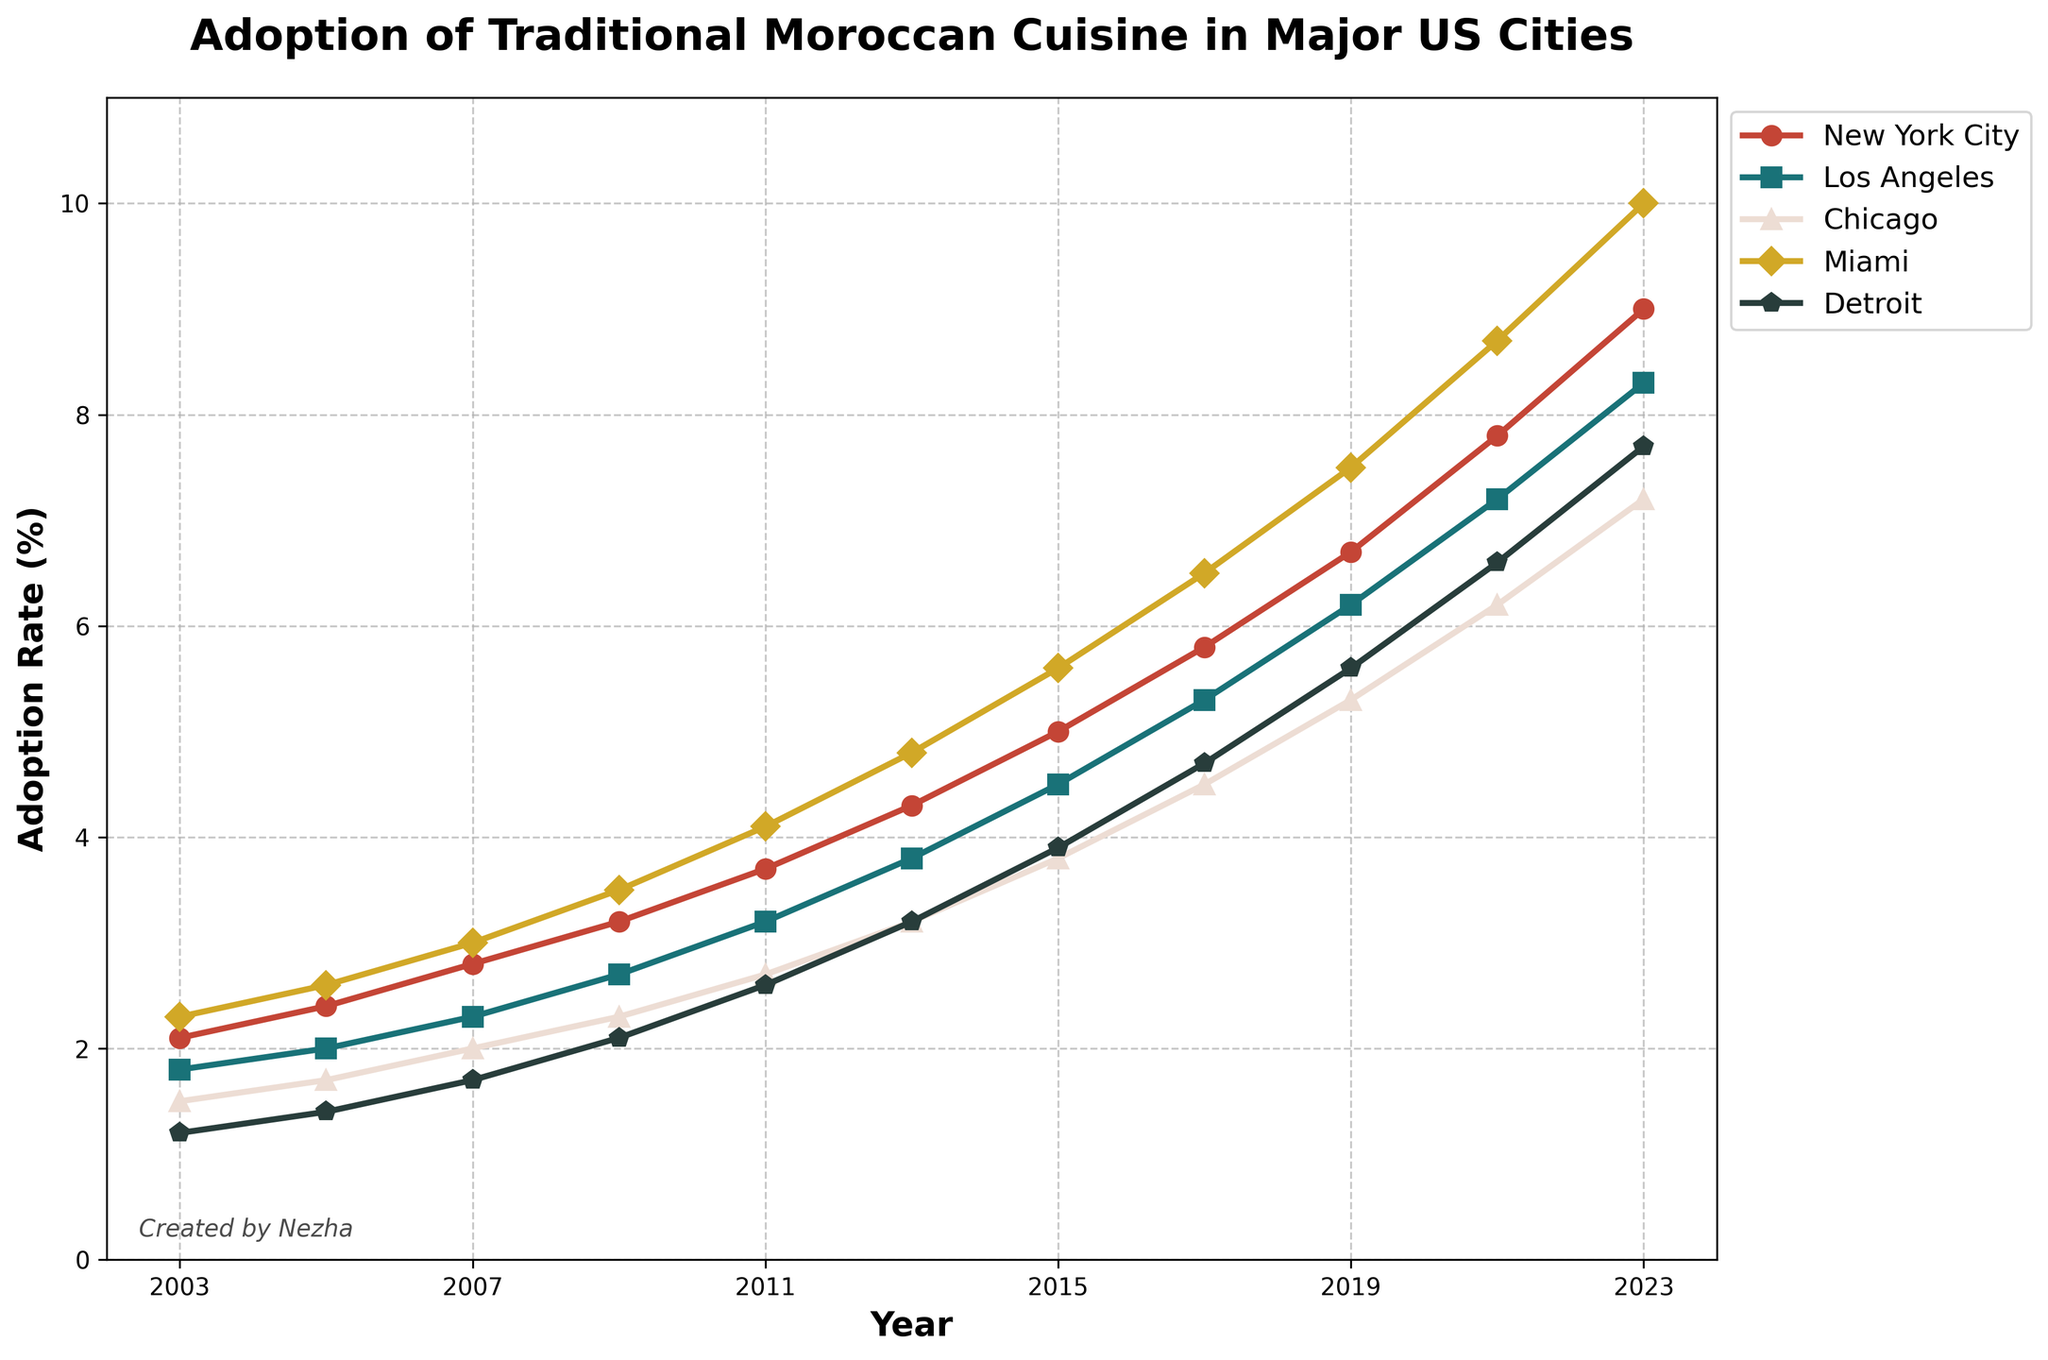Which city had the highest adoption rate of traditional Moroccan cuisine in 2023? To find the city with the highest adoption rate in 2023, we look at the data points for each city for the year 2023. Miami has the highest at 10.0%.
Answer: Miami How did the adoption rate in Detroit change from 2003 to 2023? First, identify the adoption rates in Detroit for 2003 and 2023. In 2003, it was 1.2%, and in 2023, it was 7.7%. The change is 7.7% - 1.2% = 6.5%.
Answer: Increased by 6.5% What is the average adoption rate of Moroccan cuisine in Chicago over the entire period? Sum the adoption rates in Chicago for each year and divide by the number of years: (1.5 + 1.7 + 2.0 + 2.3 + 2.7 + 3.2 + 3.8 + 4.5 + 5.3 + 6.2 + 7.2) / 11 = 3.73%.
Answer: 3.73% Which cities had an adoption rate higher than 5% in 2015? Look at the adoption rates for each city in 2015. New York City (5.0%), Los Angeles (4.5%), Chicago (3.8%), Miami (5.6%), and Detroit (3.9%). Only New York City and Miami had adoption rates higher than 5%.
Answer: New York City, Miami What was the percentage increase in adoption rate in New York City from 2009 to 2013? Find the adoption rates for New York City in 2009 and 2013. For 2009, it was 3.2%, and for 2013, it was 4.3%. The increase is (4.3% - 3.2%) / 3.2% * 100% = 34.38%.
Answer: 34.38% Which city had the smallest adoption rate increase from 2011 to 2023? Calculate the increase for each city from 2011 to 2023: New York City (9.0 - 3.7), Los Angeles (8.3 - 3.2), Chicago (7.2 - 2.7), Miami (10.0 - 4.1), Detroit (7.7 - 2.6). Chicago had the smallest increase: 7.2 - 2.7 = 4.5%.
Answer: Chicago Compare the adoption rates of Los Angeles and Detroit in 2009. Which was higher and by how much? The adoption rate in Los Angeles in 2009 was 2.7%, and in Detroit, it was 2.1%. Los Angeles had a higher rate by 2.7% - 2.1% = 0.6%.
Answer: Los Angeles by 0.6% Which year had the highest overall adoption rates across all cities? Sum the adoption rates for each year and compare. The year with the highest sum is 2023 with (9.0 + 8.3 + 7.2 + 10.0 + 7.7) = 42.2%.
Answer: 2023 